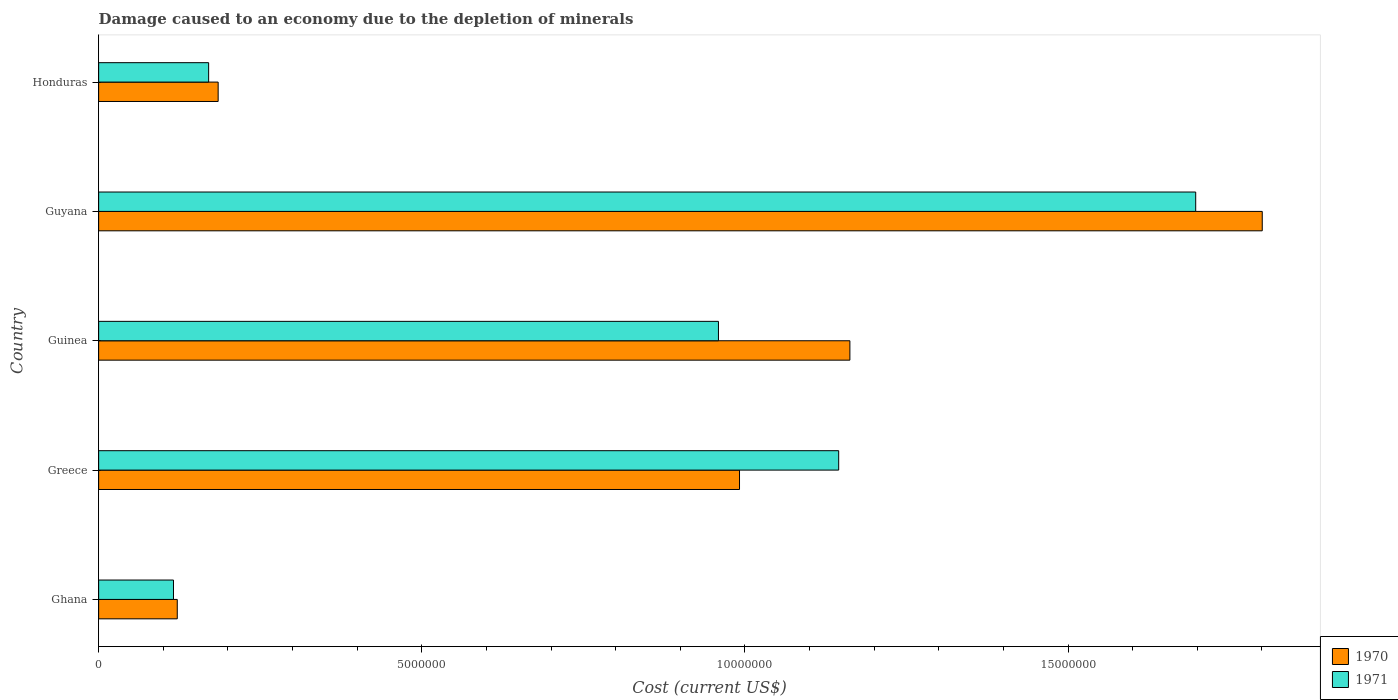How many groups of bars are there?
Offer a terse response. 5. Are the number of bars on each tick of the Y-axis equal?
Provide a succinct answer. Yes. How many bars are there on the 1st tick from the bottom?
Your answer should be compact. 2. What is the label of the 2nd group of bars from the top?
Give a very brief answer. Guyana. In how many cases, is the number of bars for a given country not equal to the number of legend labels?
Give a very brief answer. 0. What is the cost of damage caused due to the depletion of minerals in 1970 in Guyana?
Keep it short and to the point. 1.80e+07. Across all countries, what is the maximum cost of damage caused due to the depletion of minerals in 1970?
Offer a terse response. 1.80e+07. Across all countries, what is the minimum cost of damage caused due to the depletion of minerals in 1970?
Keep it short and to the point. 1.22e+06. In which country was the cost of damage caused due to the depletion of minerals in 1970 maximum?
Your answer should be compact. Guyana. In which country was the cost of damage caused due to the depletion of minerals in 1970 minimum?
Your answer should be very brief. Ghana. What is the total cost of damage caused due to the depletion of minerals in 1970 in the graph?
Your answer should be compact. 4.26e+07. What is the difference between the cost of damage caused due to the depletion of minerals in 1970 in Greece and that in Honduras?
Provide a short and direct response. 8.07e+06. What is the difference between the cost of damage caused due to the depletion of minerals in 1971 in Honduras and the cost of damage caused due to the depletion of minerals in 1970 in Greece?
Give a very brief answer. -8.21e+06. What is the average cost of damage caused due to the depletion of minerals in 1971 per country?
Make the answer very short. 8.18e+06. What is the difference between the cost of damage caused due to the depletion of minerals in 1971 and cost of damage caused due to the depletion of minerals in 1970 in Guinea?
Your response must be concise. -2.03e+06. In how many countries, is the cost of damage caused due to the depletion of minerals in 1971 greater than 10000000 US$?
Your answer should be very brief. 2. What is the ratio of the cost of damage caused due to the depletion of minerals in 1970 in Ghana to that in Honduras?
Keep it short and to the point. 0.66. Is the cost of damage caused due to the depletion of minerals in 1971 in Greece less than that in Guinea?
Give a very brief answer. No. Is the difference between the cost of damage caused due to the depletion of minerals in 1971 in Ghana and Honduras greater than the difference between the cost of damage caused due to the depletion of minerals in 1970 in Ghana and Honduras?
Provide a succinct answer. Yes. What is the difference between the highest and the second highest cost of damage caused due to the depletion of minerals in 1970?
Your answer should be compact. 6.38e+06. What is the difference between the highest and the lowest cost of damage caused due to the depletion of minerals in 1970?
Offer a terse response. 1.68e+07. Is the sum of the cost of damage caused due to the depletion of minerals in 1971 in Greece and Guyana greater than the maximum cost of damage caused due to the depletion of minerals in 1970 across all countries?
Make the answer very short. Yes. What does the 1st bar from the top in Greece represents?
Give a very brief answer. 1971. What does the 1st bar from the bottom in Greece represents?
Provide a short and direct response. 1970. How many bars are there?
Offer a very short reply. 10. What is the title of the graph?
Your answer should be very brief. Damage caused to an economy due to the depletion of minerals. Does "2015" appear as one of the legend labels in the graph?
Make the answer very short. No. What is the label or title of the X-axis?
Offer a very short reply. Cost (current US$). What is the label or title of the Y-axis?
Make the answer very short. Country. What is the Cost (current US$) in 1970 in Ghana?
Your answer should be very brief. 1.22e+06. What is the Cost (current US$) of 1971 in Ghana?
Your response must be concise. 1.16e+06. What is the Cost (current US$) in 1970 in Greece?
Your answer should be compact. 9.92e+06. What is the Cost (current US$) in 1971 in Greece?
Ensure brevity in your answer.  1.15e+07. What is the Cost (current US$) in 1970 in Guinea?
Give a very brief answer. 1.16e+07. What is the Cost (current US$) in 1971 in Guinea?
Keep it short and to the point. 9.59e+06. What is the Cost (current US$) in 1970 in Guyana?
Give a very brief answer. 1.80e+07. What is the Cost (current US$) in 1971 in Guyana?
Offer a terse response. 1.70e+07. What is the Cost (current US$) in 1970 in Honduras?
Make the answer very short. 1.85e+06. What is the Cost (current US$) in 1971 in Honduras?
Keep it short and to the point. 1.70e+06. Across all countries, what is the maximum Cost (current US$) of 1970?
Your answer should be compact. 1.80e+07. Across all countries, what is the maximum Cost (current US$) in 1971?
Keep it short and to the point. 1.70e+07. Across all countries, what is the minimum Cost (current US$) of 1970?
Your answer should be compact. 1.22e+06. Across all countries, what is the minimum Cost (current US$) in 1971?
Give a very brief answer. 1.16e+06. What is the total Cost (current US$) in 1970 in the graph?
Your response must be concise. 4.26e+07. What is the total Cost (current US$) in 1971 in the graph?
Your response must be concise. 4.09e+07. What is the difference between the Cost (current US$) of 1970 in Ghana and that in Greece?
Make the answer very short. -8.70e+06. What is the difference between the Cost (current US$) in 1971 in Ghana and that in Greece?
Offer a terse response. -1.03e+07. What is the difference between the Cost (current US$) of 1970 in Ghana and that in Guinea?
Your response must be concise. -1.04e+07. What is the difference between the Cost (current US$) of 1971 in Ghana and that in Guinea?
Offer a very short reply. -8.43e+06. What is the difference between the Cost (current US$) of 1970 in Ghana and that in Guyana?
Your response must be concise. -1.68e+07. What is the difference between the Cost (current US$) in 1971 in Ghana and that in Guyana?
Keep it short and to the point. -1.58e+07. What is the difference between the Cost (current US$) in 1970 in Ghana and that in Honduras?
Offer a very short reply. -6.33e+05. What is the difference between the Cost (current US$) of 1971 in Ghana and that in Honduras?
Your answer should be very brief. -5.44e+05. What is the difference between the Cost (current US$) of 1970 in Greece and that in Guinea?
Keep it short and to the point. -1.71e+06. What is the difference between the Cost (current US$) in 1971 in Greece and that in Guinea?
Your answer should be compact. 1.86e+06. What is the difference between the Cost (current US$) in 1970 in Greece and that in Guyana?
Offer a very short reply. -8.09e+06. What is the difference between the Cost (current US$) in 1971 in Greece and that in Guyana?
Offer a terse response. -5.52e+06. What is the difference between the Cost (current US$) in 1970 in Greece and that in Honduras?
Offer a very short reply. 8.07e+06. What is the difference between the Cost (current US$) of 1971 in Greece and that in Honduras?
Provide a short and direct response. 9.75e+06. What is the difference between the Cost (current US$) of 1970 in Guinea and that in Guyana?
Keep it short and to the point. -6.38e+06. What is the difference between the Cost (current US$) in 1971 in Guinea and that in Guyana?
Your response must be concise. -7.38e+06. What is the difference between the Cost (current US$) in 1970 in Guinea and that in Honduras?
Make the answer very short. 9.78e+06. What is the difference between the Cost (current US$) of 1971 in Guinea and that in Honduras?
Keep it short and to the point. 7.89e+06. What is the difference between the Cost (current US$) in 1970 in Guyana and that in Honduras?
Ensure brevity in your answer.  1.62e+07. What is the difference between the Cost (current US$) of 1971 in Guyana and that in Honduras?
Ensure brevity in your answer.  1.53e+07. What is the difference between the Cost (current US$) in 1970 in Ghana and the Cost (current US$) in 1971 in Greece?
Provide a short and direct response. -1.02e+07. What is the difference between the Cost (current US$) of 1970 in Ghana and the Cost (current US$) of 1971 in Guinea?
Your response must be concise. -8.37e+06. What is the difference between the Cost (current US$) of 1970 in Ghana and the Cost (current US$) of 1971 in Guyana?
Offer a terse response. -1.58e+07. What is the difference between the Cost (current US$) in 1970 in Ghana and the Cost (current US$) in 1971 in Honduras?
Offer a terse response. -4.85e+05. What is the difference between the Cost (current US$) in 1970 in Greece and the Cost (current US$) in 1971 in Guinea?
Keep it short and to the point. 3.26e+05. What is the difference between the Cost (current US$) in 1970 in Greece and the Cost (current US$) in 1971 in Guyana?
Keep it short and to the point. -7.06e+06. What is the difference between the Cost (current US$) in 1970 in Greece and the Cost (current US$) in 1971 in Honduras?
Your response must be concise. 8.21e+06. What is the difference between the Cost (current US$) of 1970 in Guinea and the Cost (current US$) of 1971 in Guyana?
Give a very brief answer. -5.35e+06. What is the difference between the Cost (current US$) in 1970 in Guinea and the Cost (current US$) in 1971 in Honduras?
Provide a succinct answer. 9.92e+06. What is the difference between the Cost (current US$) of 1970 in Guyana and the Cost (current US$) of 1971 in Honduras?
Ensure brevity in your answer.  1.63e+07. What is the average Cost (current US$) in 1970 per country?
Your answer should be very brief. 8.52e+06. What is the average Cost (current US$) in 1971 per country?
Offer a terse response. 8.18e+06. What is the difference between the Cost (current US$) in 1970 and Cost (current US$) in 1971 in Ghana?
Your response must be concise. 5.86e+04. What is the difference between the Cost (current US$) in 1970 and Cost (current US$) in 1971 in Greece?
Your answer should be very brief. -1.53e+06. What is the difference between the Cost (current US$) in 1970 and Cost (current US$) in 1971 in Guinea?
Offer a terse response. 2.03e+06. What is the difference between the Cost (current US$) of 1970 and Cost (current US$) of 1971 in Guyana?
Your response must be concise. 1.03e+06. What is the difference between the Cost (current US$) of 1970 and Cost (current US$) of 1971 in Honduras?
Your answer should be very brief. 1.47e+05. What is the ratio of the Cost (current US$) of 1970 in Ghana to that in Greece?
Your response must be concise. 0.12. What is the ratio of the Cost (current US$) in 1971 in Ghana to that in Greece?
Your answer should be very brief. 0.1. What is the ratio of the Cost (current US$) of 1970 in Ghana to that in Guinea?
Offer a terse response. 0.1. What is the ratio of the Cost (current US$) of 1971 in Ghana to that in Guinea?
Offer a very short reply. 0.12. What is the ratio of the Cost (current US$) of 1970 in Ghana to that in Guyana?
Offer a very short reply. 0.07. What is the ratio of the Cost (current US$) of 1971 in Ghana to that in Guyana?
Make the answer very short. 0.07. What is the ratio of the Cost (current US$) in 1970 in Ghana to that in Honduras?
Make the answer very short. 0.66. What is the ratio of the Cost (current US$) of 1971 in Ghana to that in Honduras?
Keep it short and to the point. 0.68. What is the ratio of the Cost (current US$) of 1970 in Greece to that in Guinea?
Offer a very short reply. 0.85. What is the ratio of the Cost (current US$) of 1971 in Greece to that in Guinea?
Keep it short and to the point. 1.19. What is the ratio of the Cost (current US$) of 1970 in Greece to that in Guyana?
Your response must be concise. 0.55. What is the ratio of the Cost (current US$) in 1971 in Greece to that in Guyana?
Your answer should be compact. 0.67. What is the ratio of the Cost (current US$) in 1970 in Greece to that in Honduras?
Keep it short and to the point. 5.36. What is the ratio of the Cost (current US$) of 1971 in Greece to that in Honduras?
Offer a terse response. 6.73. What is the ratio of the Cost (current US$) in 1970 in Guinea to that in Guyana?
Offer a terse response. 0.65. What is the ratio of the Cost (current US$) of 1971 in Guinea to that in Guyana?
Your answer should be very brief. 0.56. What is the ratio of the Cost (current US$) in 1970 in Guinea to that in Honduras?
Ensure brevity in your answer.  6.29. What is the ratio of the Cost (current US$) of 1971 in Guinea to that in Honduras?
Provide a succinct answer. 5.63. What is the ratio of the Cost (current US$) of 1970 in Guyana to that in Honduras?
Offer a very short reply. 9.74. What is the ratio of the Cost (current US$) of 1971 in Guyana to that in Honduras?
Offer a terse response. 9.97. What is the difference between the highest and the second highest Cost (current US$) of 1970?
Provide a succinct answer. 6.38e+06. What is the difference between the highest and the second highest Cost (current US$) in 1971?
Your answer should be compact. 5.52e+06. What is the difference between the highest and the lowest Cost (current US$) of 1970?
Offer a very short reply. 1.68e+07. What is the difference between the highest and the lowest Cost (current US$) in 1971?
Your answer should be very brief. 1.58e+07. 